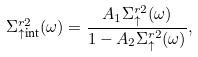<formula> <loc_0><loc_0><loc_500><loc_500>\Sigma _ { \uparrow \text {int} } ^ { r 2 } ( \omega ) = \frac { A _ { 1 } \Sigma _ { \uparrow } ^ { r 2 } ( \omega ) } { 1 - A _ { 2 } \Sigma _ { \uparrow } ^ { r 2 } ( \omega ) } ,</formula> 